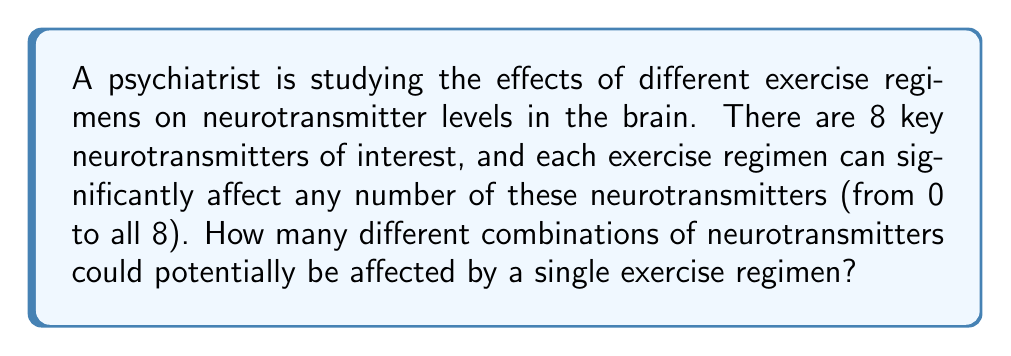Help me with this question. To solve this problem, we need to consider the following:

1. Each neurotransmitter has two possible states: affected or not affected by the exercise regimen.

2. There are 8 neurotransmitters in total.

3. We need to calculate all possible combinations, including the case where no neurotransmitters are affected and the case where all are affected.

This scenario is a perfect application of the power set concept in combinatorics. The power set of a set S is the set of all subsets of S, including the empty set and S itself.

The number of elements in a power set is given by the formula:

$$ 2^n $$

Where n is the number of elements in the original set.

In our case:
$$ n = 8 \text{ (number of neurotransmitters)} $$

Therefore, the number of possible combinations is:

$$ 2^8 = 256 $$

We can break this down further:
- 1 way to select 0 neurotransmitters (none affected)
- 8 ways to select 1 neurotransmitter ($\binom{8}{1}$)
- 28 ways to select 2 neurotransmitters ($\binom{8}{2}$)
- 56 ways to select 3 neurotransmitters ($\binom{8}{3}$)
- 70 ways to select 4 neurotransmitters ($\binom{8}{4}$)
- 56 ways to select 5 neurotransmitters ($\binom{8}{5}$)
- 28 ways to select 6 neurotransmitters ($\binom{8}{6}$)
- 8 ways to select 7 neurotransmitters ($\binom{8}{7}$)
- 1 way to select all 8 neurotransmitters

The sum of these is indeed $1 + 8 + 28 + 56 + 70 + 56 + 28 + 8 + 1 = 256$.
Answer: 256 combinations 